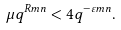<formula> <loc_0><loc_0><loc_500><loc_500>\mu q ^ { R m n } < 4 q ^ { - \varepsilon m n } .</formula> 